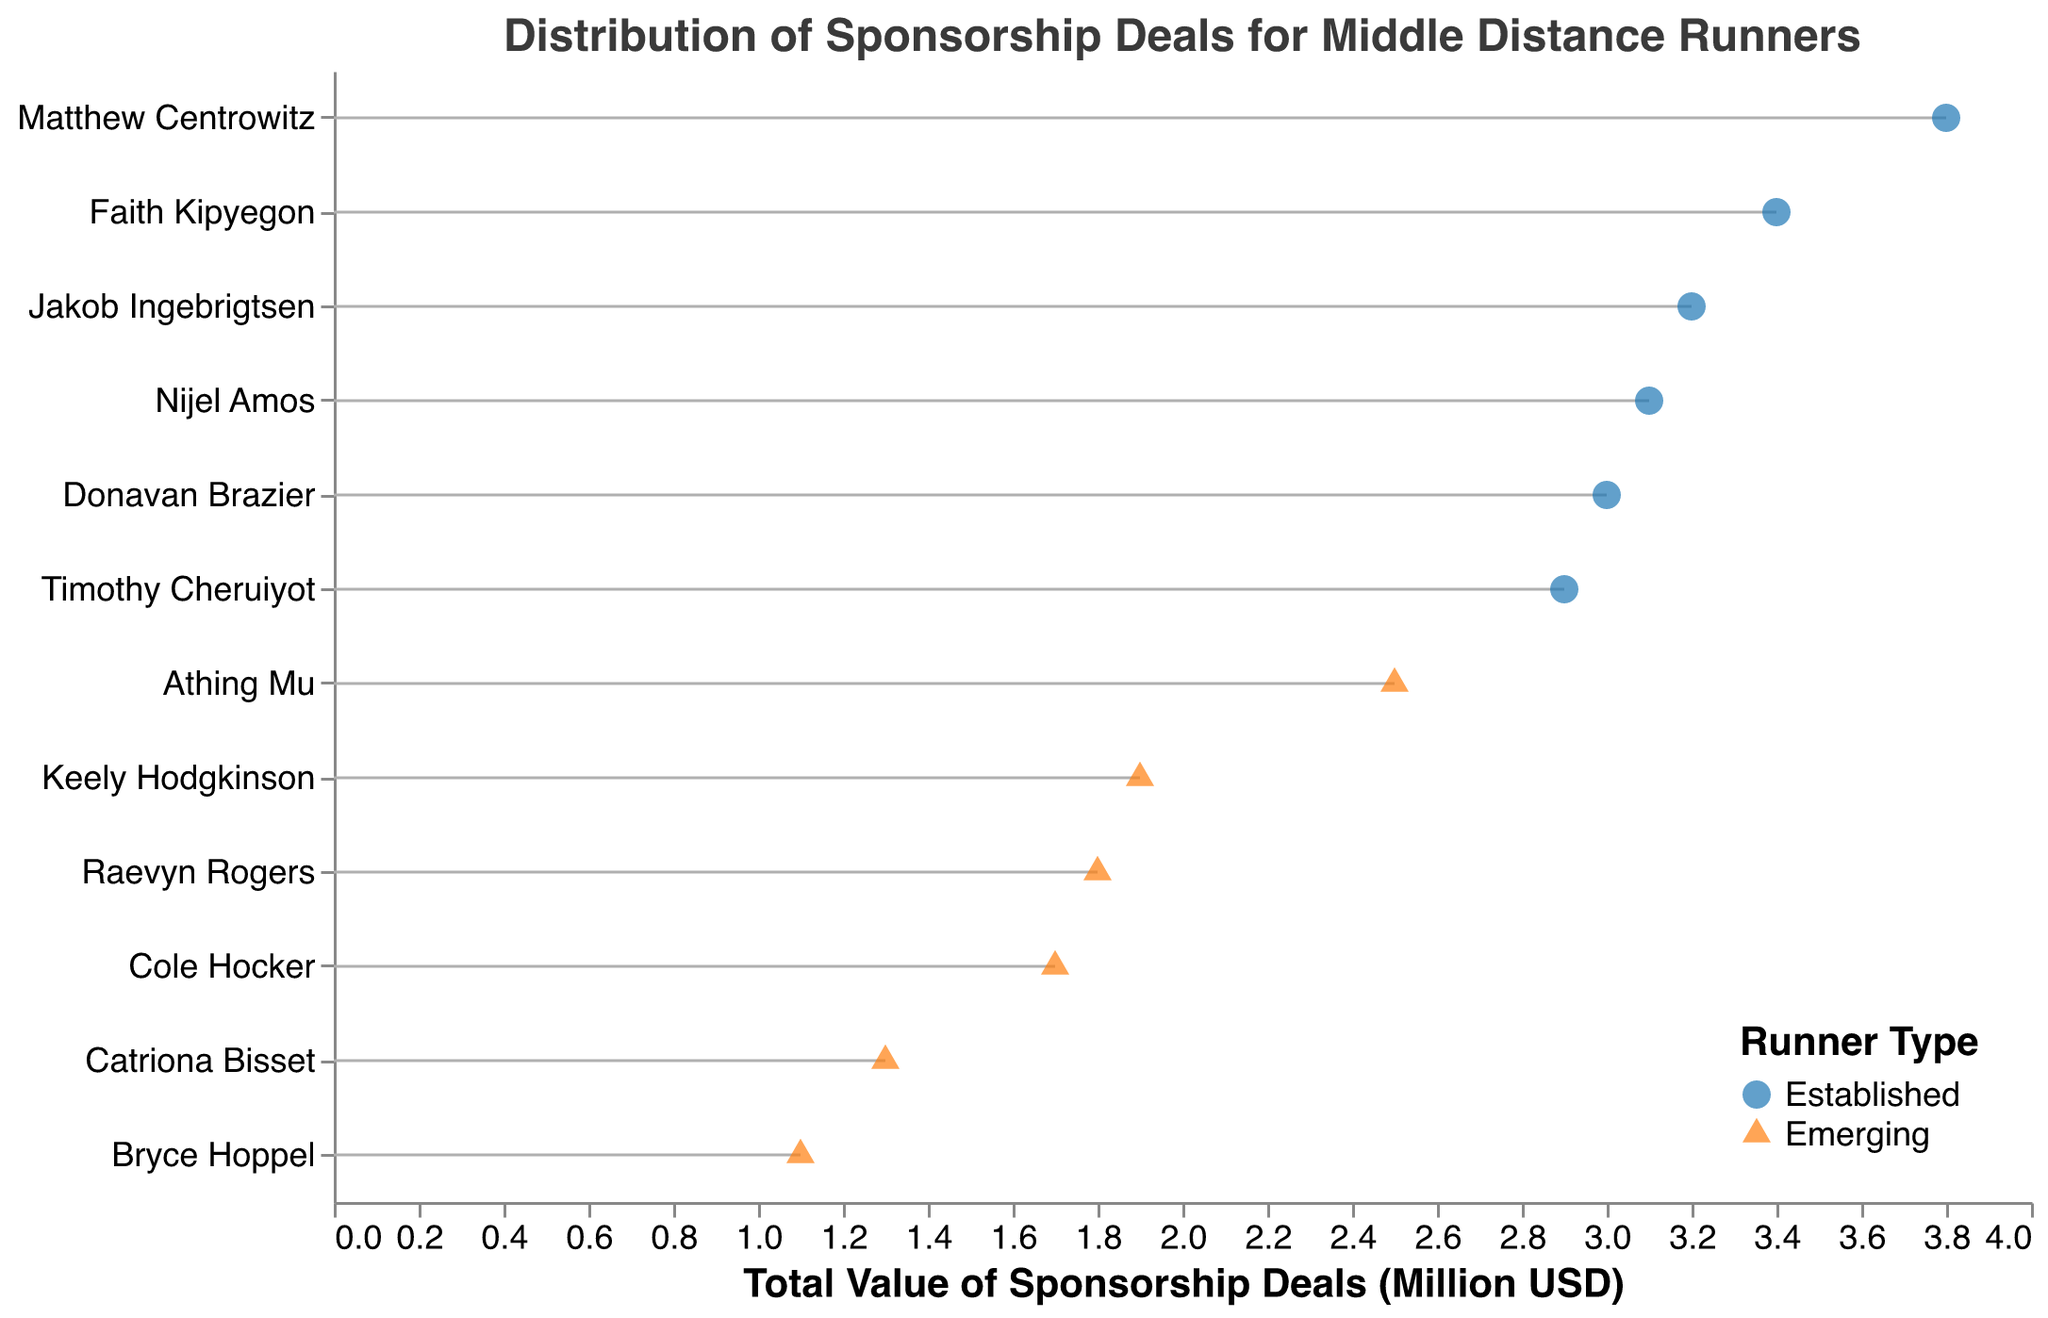What's the title of the plot? The title is clearly shown at the top of the plot. It states: "Distribution of Sponsorship Deals for Middle Distance Runners".
Answer: Distribution of Sponsorship Deals for Middle Distance Runners Which runner has the highest total value of sponsorship deals among the established runners? By examining the established runners, Matthew Centrowitz has the highest total value with 3.8 million USD as shown by the uppermost point on the x-axis for this group.
Answer: Matthew Centrowitz How many data points represent emerging runners? Looking at the legend and the shapes for "Emerging", we count the orange triangles. There are 6 such points representing the emerging runners on the plot.
Answer: 6 What’s the total value of sponsorship deals for Faith Kipyegon? Locate Faith Kipyegon on the y-axis and see her position on the x-axis. The value aligned with her is 3.4 million USD.
Answer: 3.4 million USD What's the difference in total sponsorship value between Athing Mu and Bryce Hoppel? Athing Mu has a value of 2.5 million USD, and Bryce Hoppel has 1.1 million USD. The difference between them is calculated as 2.5 - 1.1 = 1.4 million USD.
Answer: 1.4 million USD Which established runner has the lowest sponsorship count and what is the total value associated with it? Among the established runners, Timothy Cheruiyot has the lowest sponsorship count with 4 deals. His total value is 2.9 million USD.
Answer: Timothy Cheruiyot, 2.9 million USD How does the average total sponsorship value for established runners compare to emerging runners? Calculate the mean for each group. Established: (3.2 + 2.9 + 3.1 + 3.8 + 3.4 + 3.0) / 6 = 19.4/6 ≈ 3.23 million USD. Emerging: (1.7 + 1.1 + 2.5 + 1.9 + 1.3 + 1.8) / 6 = 10.3/6 ≈ 1.72 million USD. Established runners have a higher average total sponsorship value.
Answer: Established ≈ 3.23 million USD, Emerging ≈ 1.72 million USD Which emerging runner has the highest total value of sponsorship deals and what is the value? Among the emerging runners, Athing Mu has the highest total value which is 2.5 million USD.
Answer: Athing Mu, 2.5 million USD Is there any runner with both high sponsorship count (5 or more deals) and a low total value (below 3 million USD)? By examining the runners with 5 or more deals, all have total values 3 million USD or higher. Thus, there is no such runner with high count and low value.
Answer: No 